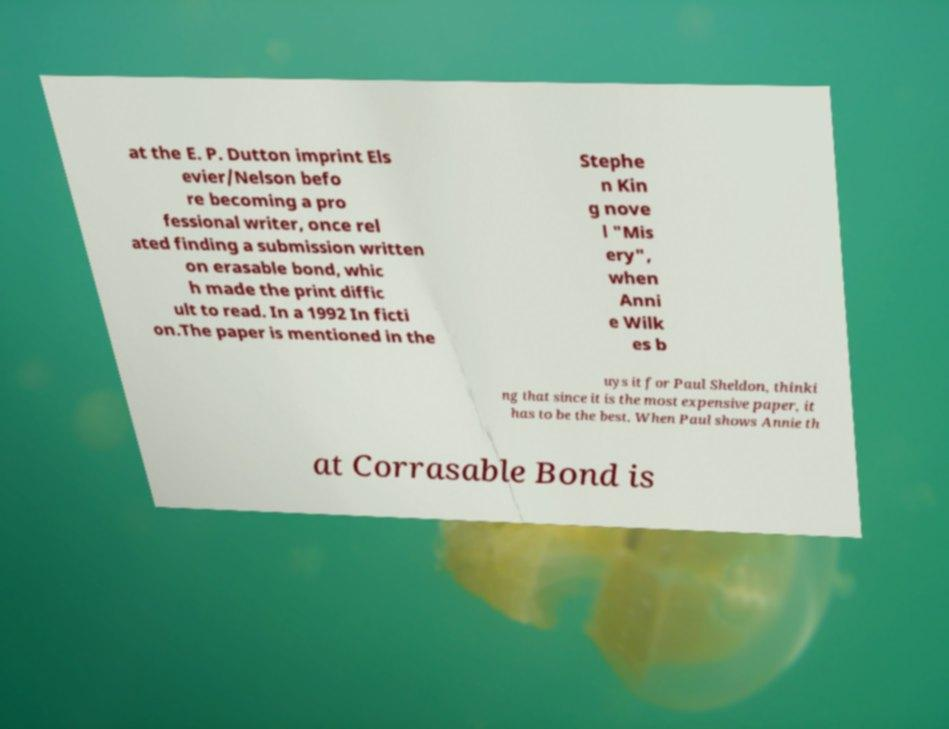Can you accurately transcribe the text from the provided image for me? at the E. P. Dutton imprint Els evier/Nelson befo re becoming a pro fessional writer, once rel ated finding a submission written on erasable bond, whic h made the print diffic ult to read. In a 1992 In ficti on.The paper is mentioned in the Stephe n Kin g nove l "Mis ery", when Anni e Wilk es b uys it for Paul Sheldon, thinki ng that since it is the most expensive paper, it has to be the best. When Paul shows Annie th at Corrasable Bond is 